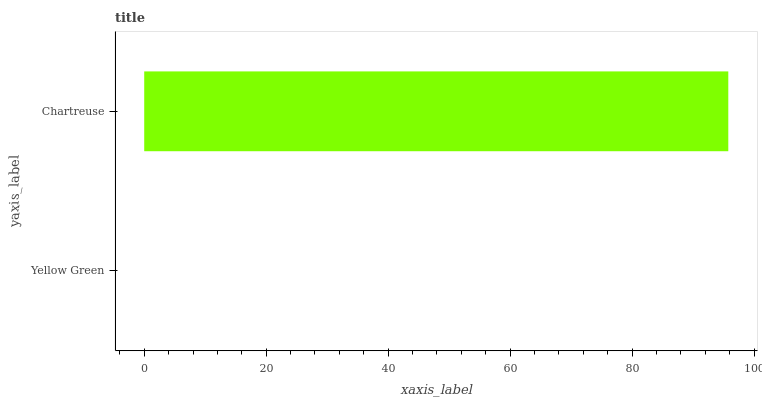Is Yellow Green the minimum?
Answer yes or no. Yes. Is Chartreuse the maximum?
Answer yes or no. Yes. Is Chartreuse the minimum?
Answer yes or no. No. Is Chartreuse greater than Yellow Green?
Answer yes or no. Yes. Is Yellow Green less than Chartreuse?
Answer yes or no. Yes. Is Yellow Green greater than Chartreuse?
Answer yes or no. No. Is Chartreuse less than Yellow Green?
Answer yes or no. No. Is Chartreuse the high median?
Answer yes or no. Yes. Is Yellow Green the low median?
Answer yes or no. Yes. Is Yellow Green the high median?
Answer yes or no. No. Is Chartreuse the low median?
Answer yes or no. No. 